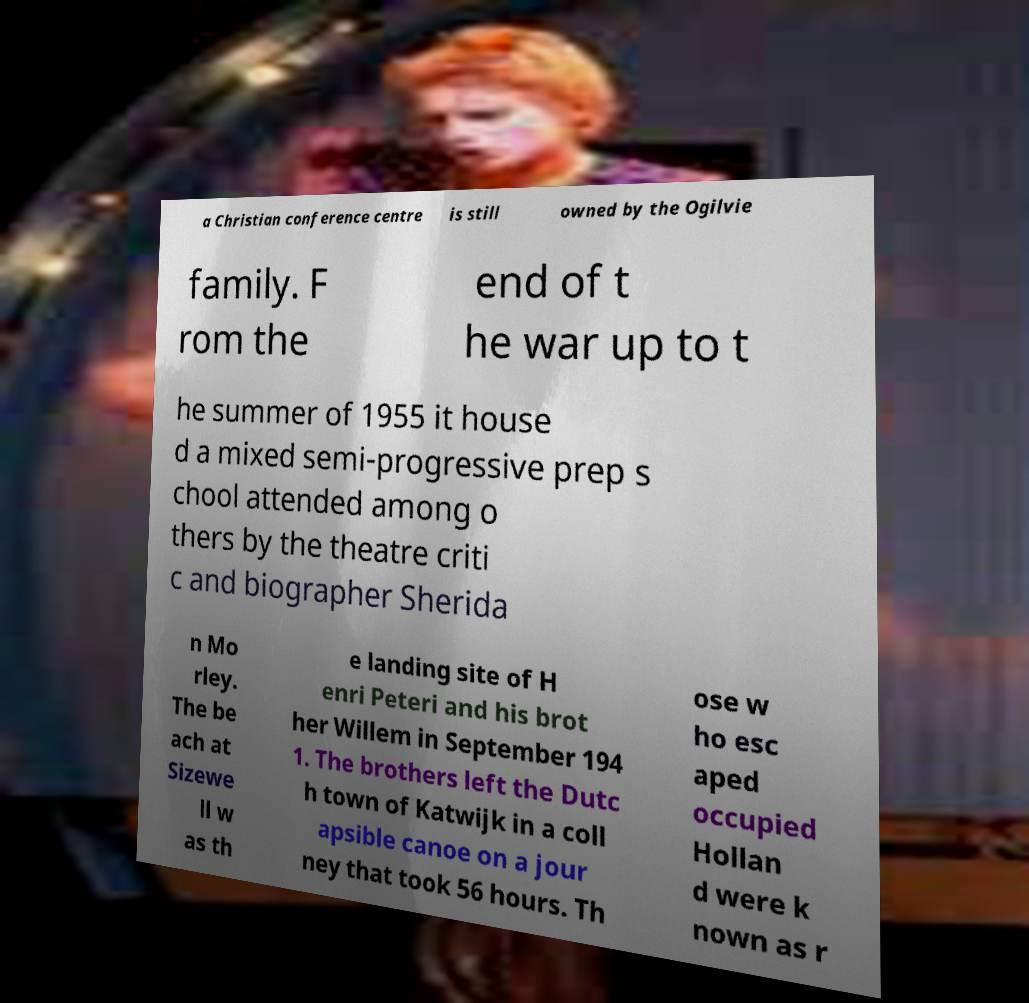For documentation purposes, I need the text within this image transcribed. Could you provide that? a Christian conference centre is still owned by the Ogilvie family. F rom the end of t he war up to t he summer of 1955 it house d a mixed semi-progressive prep s chool attended among o thers by the theatre criti c and biographer Sherida n Mo rley. The be ach at Sizewe ll w as th e landing site of H enri Peteri and his brot her Willem in September 194 1. The brothers left the Dutc h town of Katwijk in a coll apsible canoe on a jour ney that took 56 hours. Th ose w ho esc aped occupied Hollan d were k nown as r 